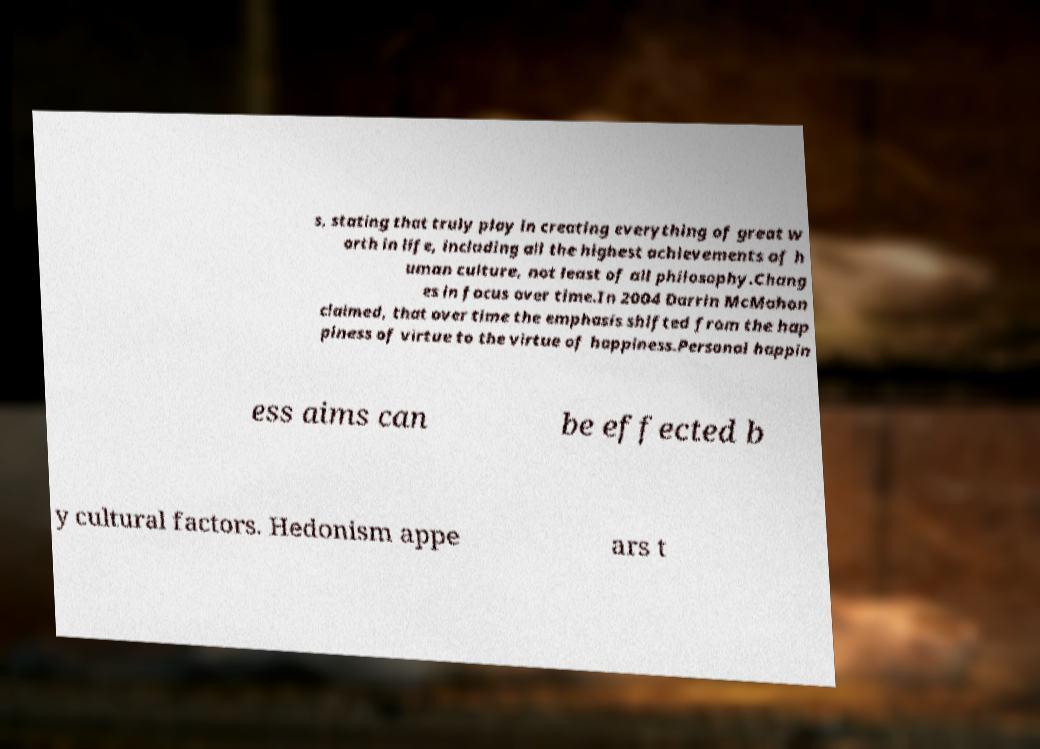For documentation purposes, I need the text within this image transcribed. Could you provide that? s, stating that truly play in creating everything of great w orth in life, including all the highest achievements of h uman culture, not least of all philosophy.Chang es in focus over time.In 2004 Darrin McMahon claimed, that over time the emphasis shifted from the hap piness of virtue to the virtue of happiness.Personal happin ess aims can be effected b y cultural factors. Hedonism appe ars t 